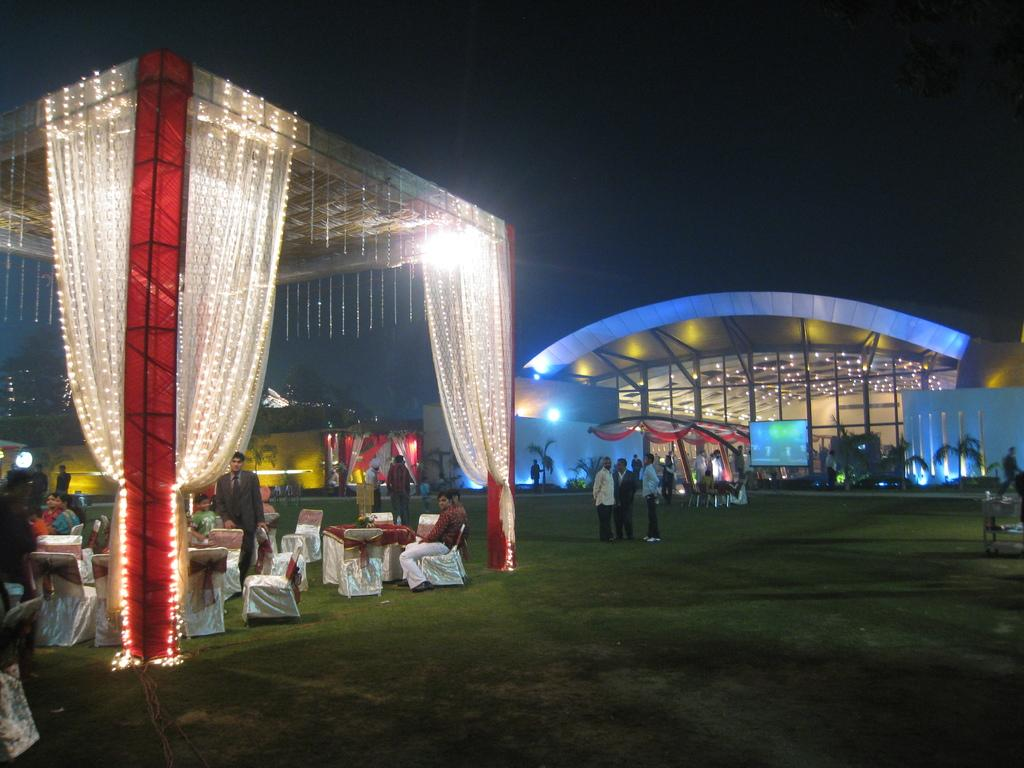What is happening with the group of people in the image? The group of people is on the ground in the image. What objects are present for sitting in the image? There are chairs in the image. What type of natural elements can be seen in the image? There are trees in the image. What type of artificial lighting is present in the image? There are lights in the image. What additional objects can be seen in the image? There are decorative objects in the image. How would you describe the overall lighting in the image? The background of the image appears to be dark. What type of face can be seen in the image? There is no face present in the image. 